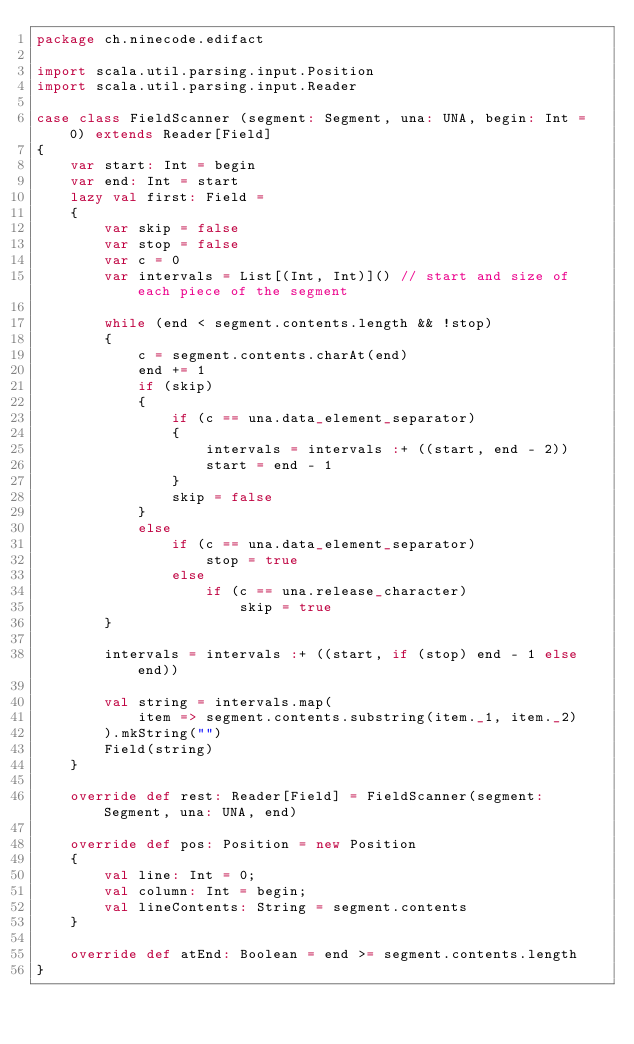Convert code to text. <code><loc_0><loc_0><loc_500><loc_500><_Scala_>package ch.ninecode.edifact

import scala.util.parsing.input.Position
import scala.util.parsing.input.Reader

case class FieldScanner (segment: Segment, una: UNA, begin: Int = 0) extends Reader[Field]
{
    var start: Int = begin
    var end: Int = start
    lazy val first: Field =
    {
        var skip = false
        var stop = false
        var c = 0
        var intervals = List[(Int, Int)]() // start and size of each piece of the segment

        while (end < segment.contents.length && !stop)
        {
            c = segment.contents.charAt(end)
            end += 1
            if (skip)
            {
                if (c == una.data_element_separator)
                {
                    intervals = intervals :+ ((start, end - 2))
                    start = end - 1
                }
                skip = false
            }
            else
                if (c == una.data_element_separator)
                    stop = true
                else
                    if (c == una.release_character)
                        skip = true
        }

        intervals = intervals :+ ((start, if (stop) end - 1 else end))

        val string = intervals.map(
            item => segment.contents.substring(item._1, item._2)
        ).mkString("")
        Field(string)
    }

    override def rest: Reader[Field] = FieldScanner(segment: Segment, una: UNA, end)

    override def pos: Position = new Position
    {
        val line: Int = 0;
        val column: Int = begin;
        val lineContents: String = segment.contents
    }

    override def atEnd: Boolean = end >= segment.contents.length
}
</code> 